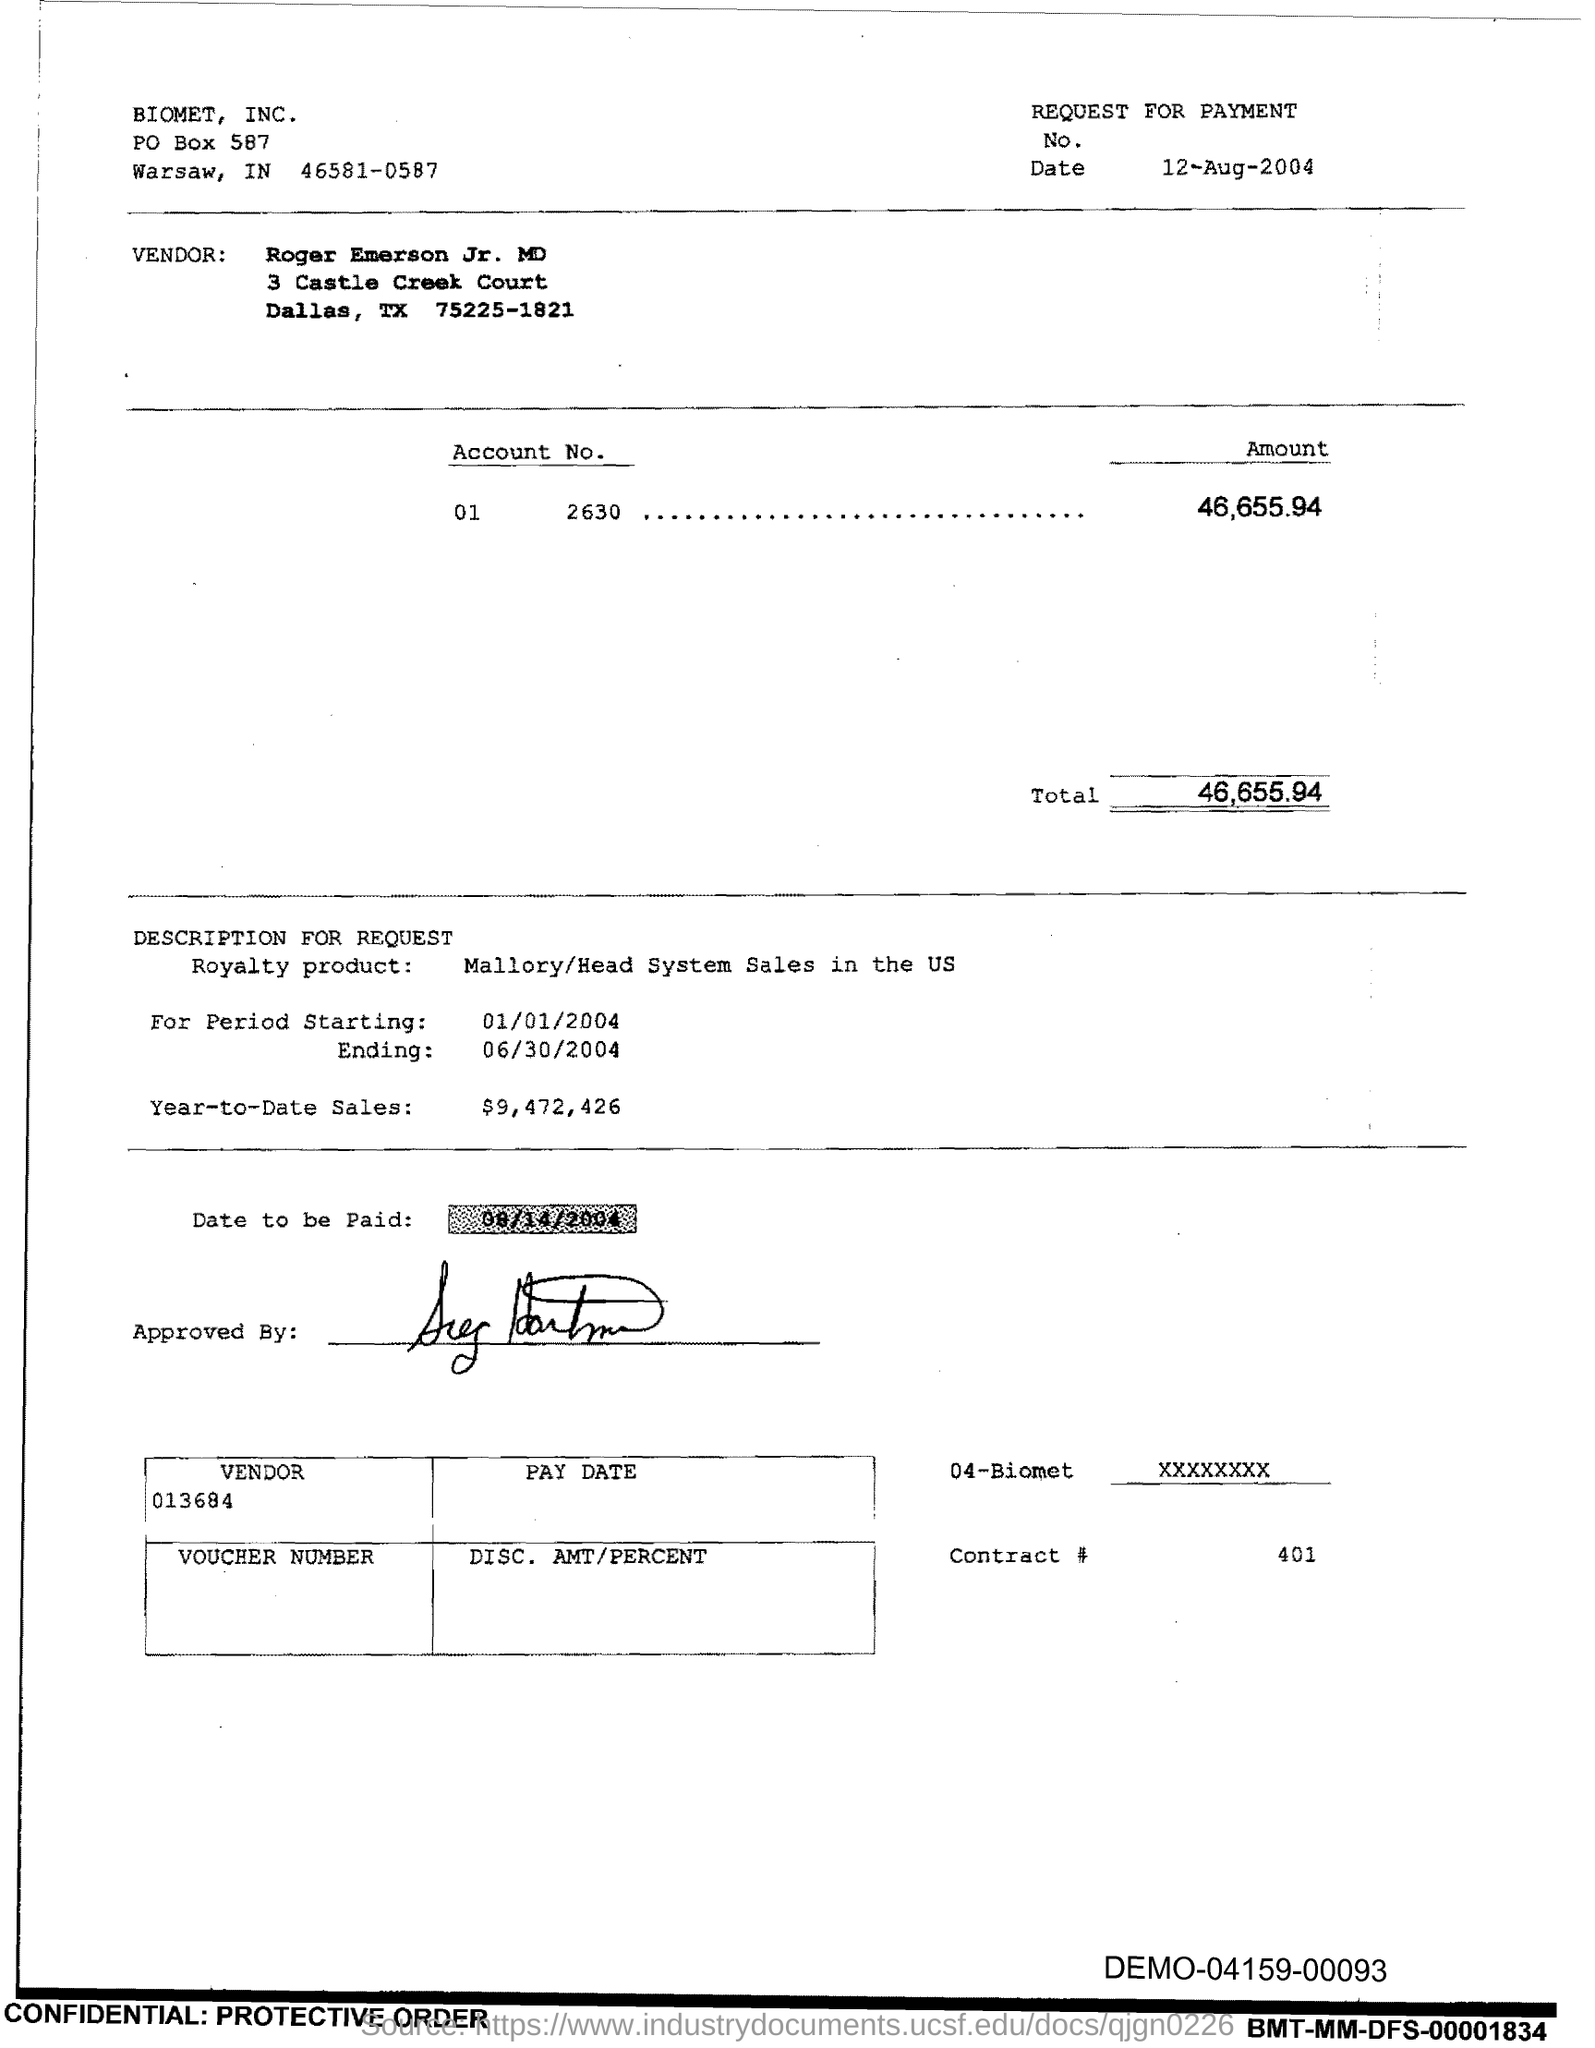Indicate a few pertinent items in this graphic. The total is 46,655.94... The year-to-date sales as of now is $9,472,426. 